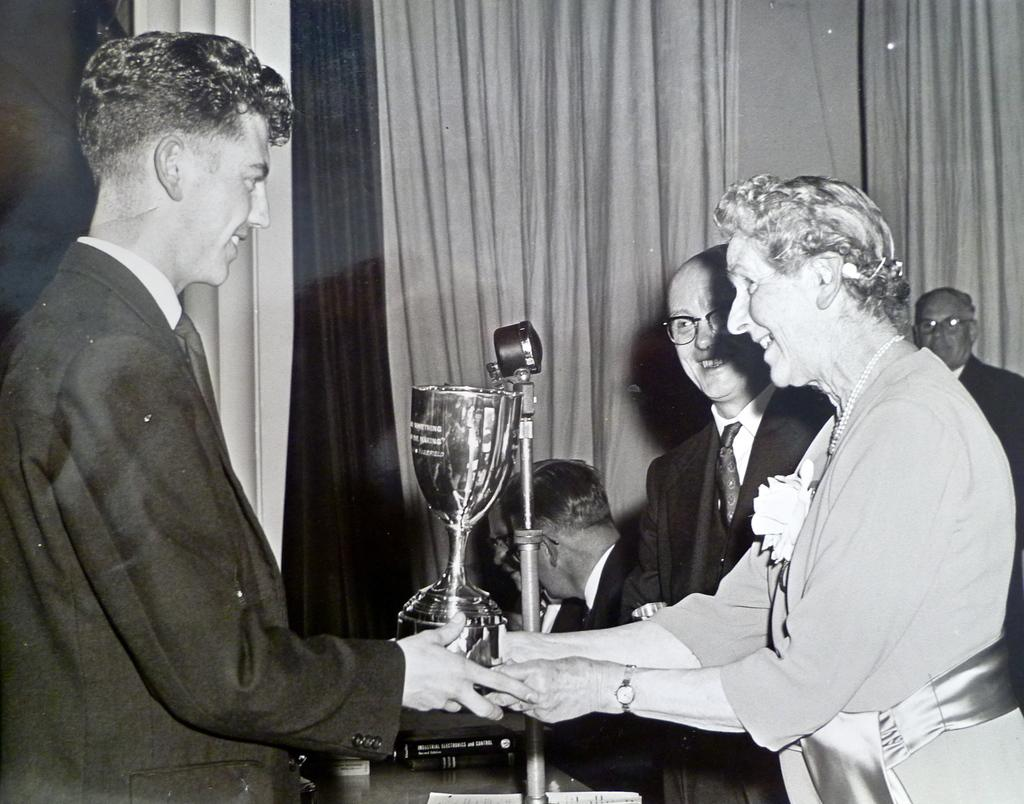How many people are visible in the image? There are two persons standing in the image. What are the two persons holding in their hands? The two persons are holding a gold cup in their hands. Can you describe the people in the background? There are other persons in the background, but their specific actions or features cannot be determined from the provided facts. What type of ray is swimming in the gold cup held by the two persons? There is no ray present in the image; the two persons are holding a gold cup, but there is no indication of any aquatic creatures inside it. 